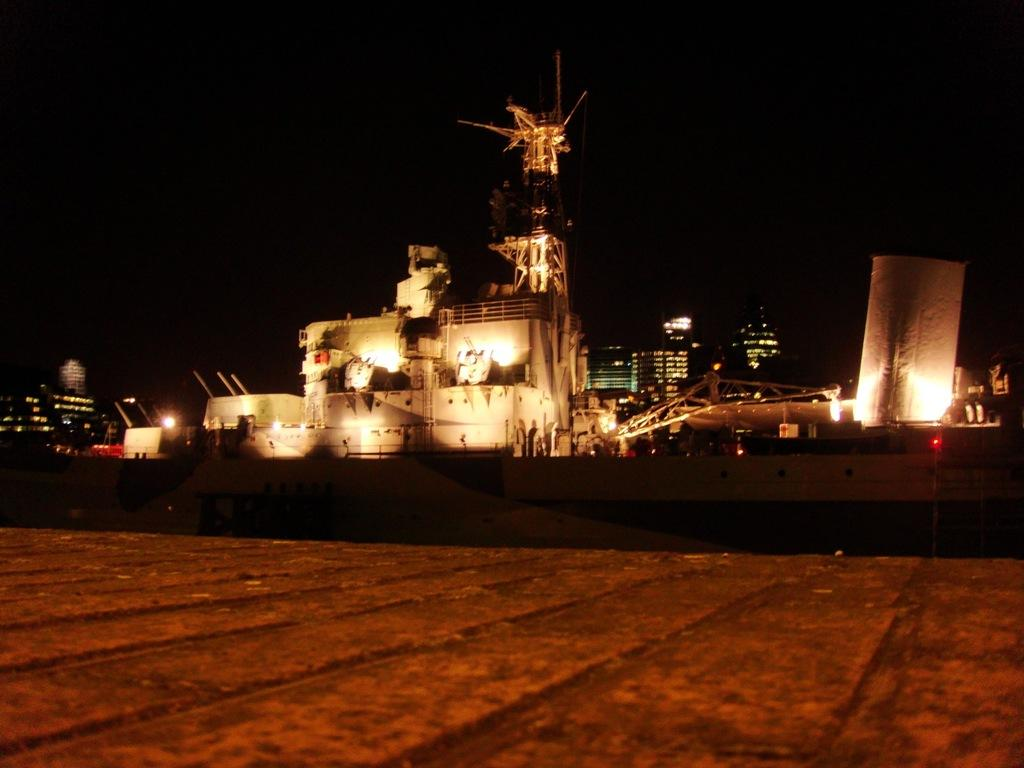What is the main subject of the image? There is a ship in the image. What can be seen in the background of the image? There are buildings visible behind the ship. What type of surface is visible at the bottom of the image? There is land visible at the bottom of the image. What type of stick is being used by the organization in the image? There is no stick or organization present in the image. 